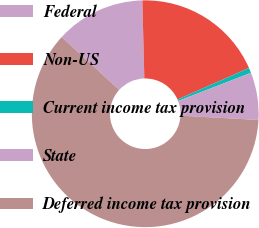Convert chart. <chart><loc_0><loc_0><loc_500><loc_500><pie_chart><fcel>Federal<fcel>Non-US<fcel>Current income tax provision<fcel>State<fcel>Deferred income tax provision<nl><fcel>12.77%<fcel>18.8%<fcel>0.73%<fcel>6.75%<fcel>60.95%<nl></chart> 